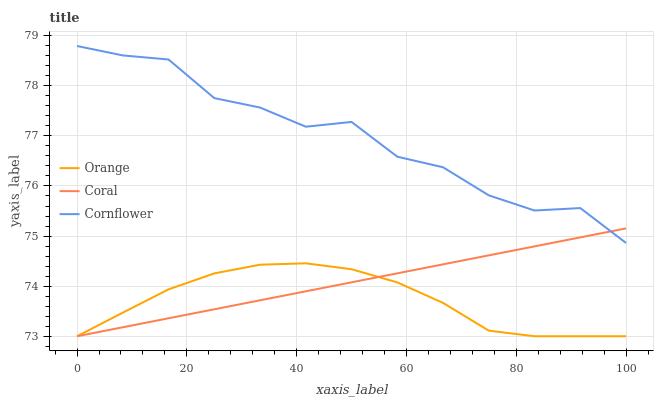Does Orange have the minimum area under the curve?
Answer yes or no. Yes. Does Cornflower have the maximum area under the curve?
Answer yes or no. Yes. Does Coral have the minimum area under the curve?
Answer yes or no. No. Does Coral have the maximum area under the curve?
Answer yes or no. No. Is Coral the smoothest?
Answer yes or no. Yes. Is Cornflower the roughest?
Answer yes or no. Yes. Is Cornflower the smoothest?
Answer yes or no. No. Is Coral the roughest?
Answer yes or no. No. Does Orange have the lowest value?
Answer yes or no. Yes. Does Cornflower have the lowest value?
Answer yes or no. No. Does Cornflower have the highest value?
Answer yes or no. Yes. Does Coral have the highest value?
Answer yes or no. No. Is Orange less than Cornflower?
Answer yes or no. Yes. Is Cornflower greater than Orange?
Answer yes or no. Yes. Does Orange intersect Coral?
Answer yes or no. Yes. Is Orange less than Coral?
Answer yes or no. No. Is Orange greater than Coral?
Answer yes or no. No. Does Orange intersect Cornflower?
Answer yes or no. No. 